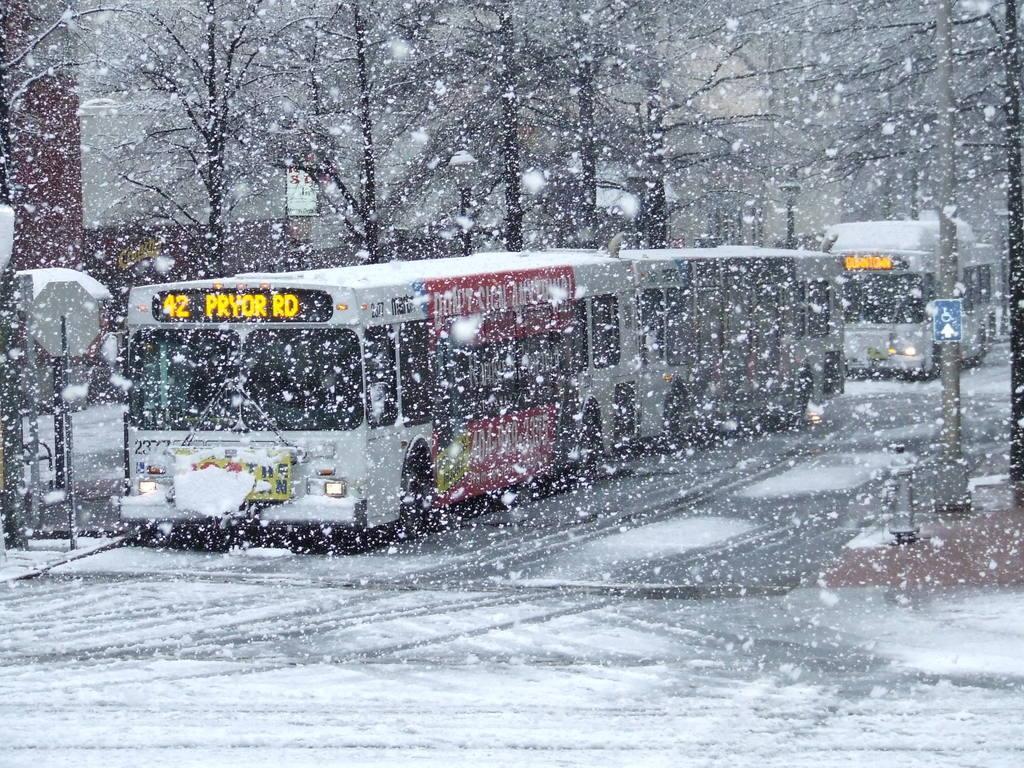In one or two sentences, can you explain what this image depicts? In this image we can see buses, light poles, buildings, sign boards, also we can see the snow, and trees. 